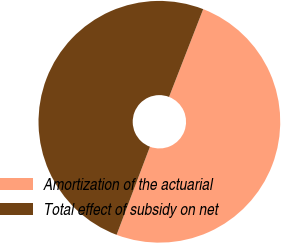Convert chart. <chart><loc_0><loc_0><loc_500><loc_500><pie_chart><fcel>Amortization of the actuarial<fcel>Total effect of subsidy on net<nl><fcel>49.85%<fcel>50.15%<nl></chart> 